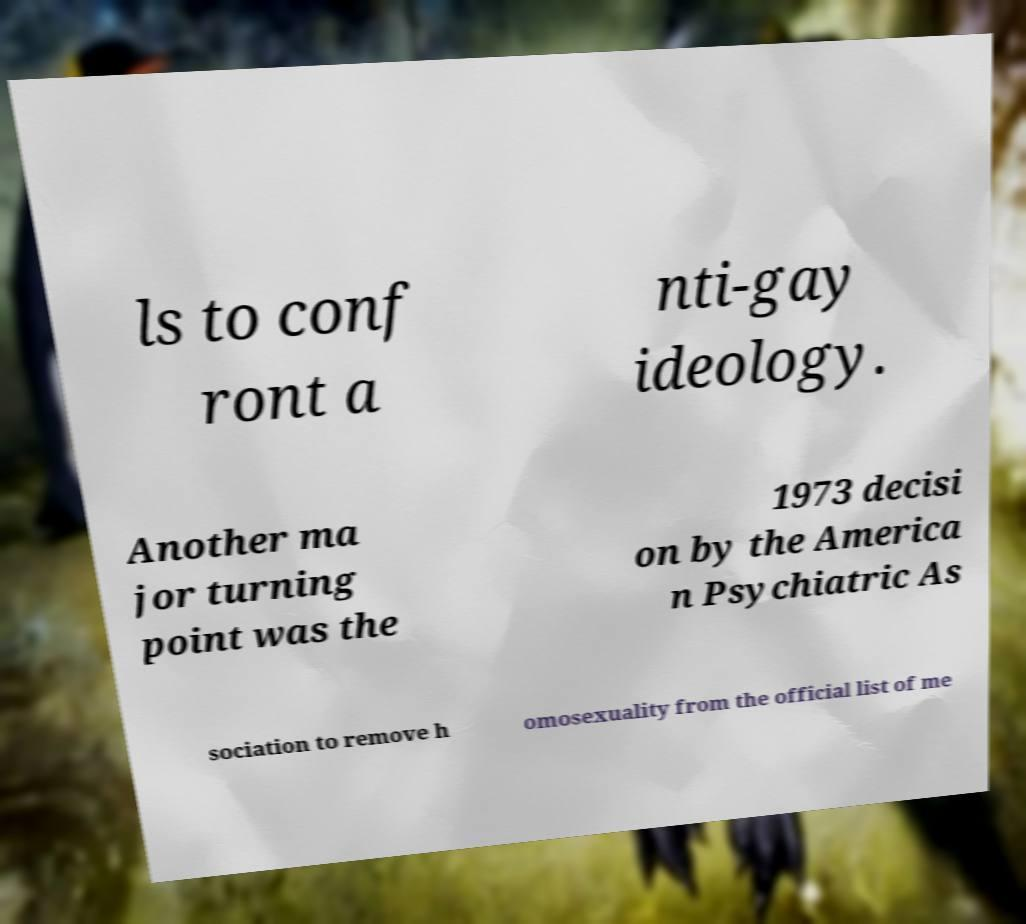Please read and relay the text visible in this image. What does it say? ls to conf ront a nti-gay ideology. Another ma jor turning point was the 1973 decisi on by the America n Psychiatric As sociation to remove h omosexuality from the official list of me 